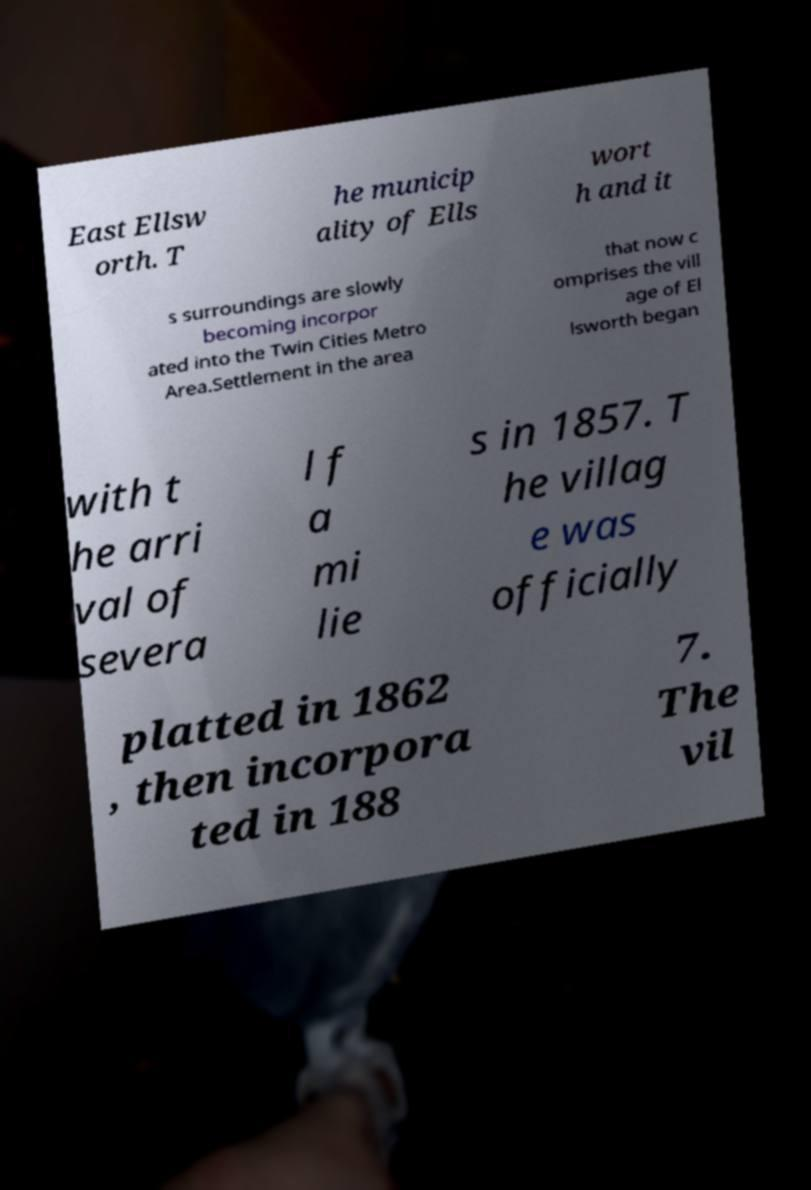What messages or text are displayed in this image? I need them in a readable, typed format. East Ellsw orth. T he municip ality of Ells wort h and it s surroundings are slowly becoming incorpor ated into the Twin Cities Metro Area.Settlement in the area that now c omprises the vill age of El lsworth began with t he arri val of severa l f a mi lie s in 1857. T he villag e was officially platted in 1862 , then incorpora ted in 188 7. The vil 